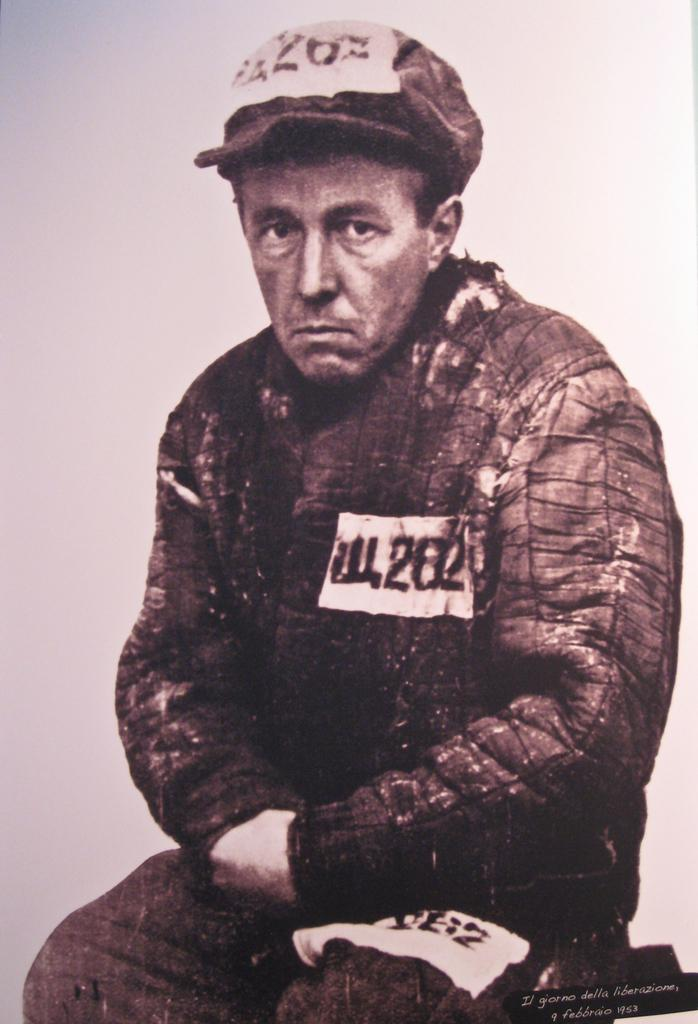What is the main subject of the image? There is a person sitting in the image. What is the person wearing on their head? The person is wearing a cap. What is the color scheme of the image? The image is in black and white. What time is it in the image? The time cannot be determined from the image, as it is in black and white and does not include any clocks or time-related elements. 